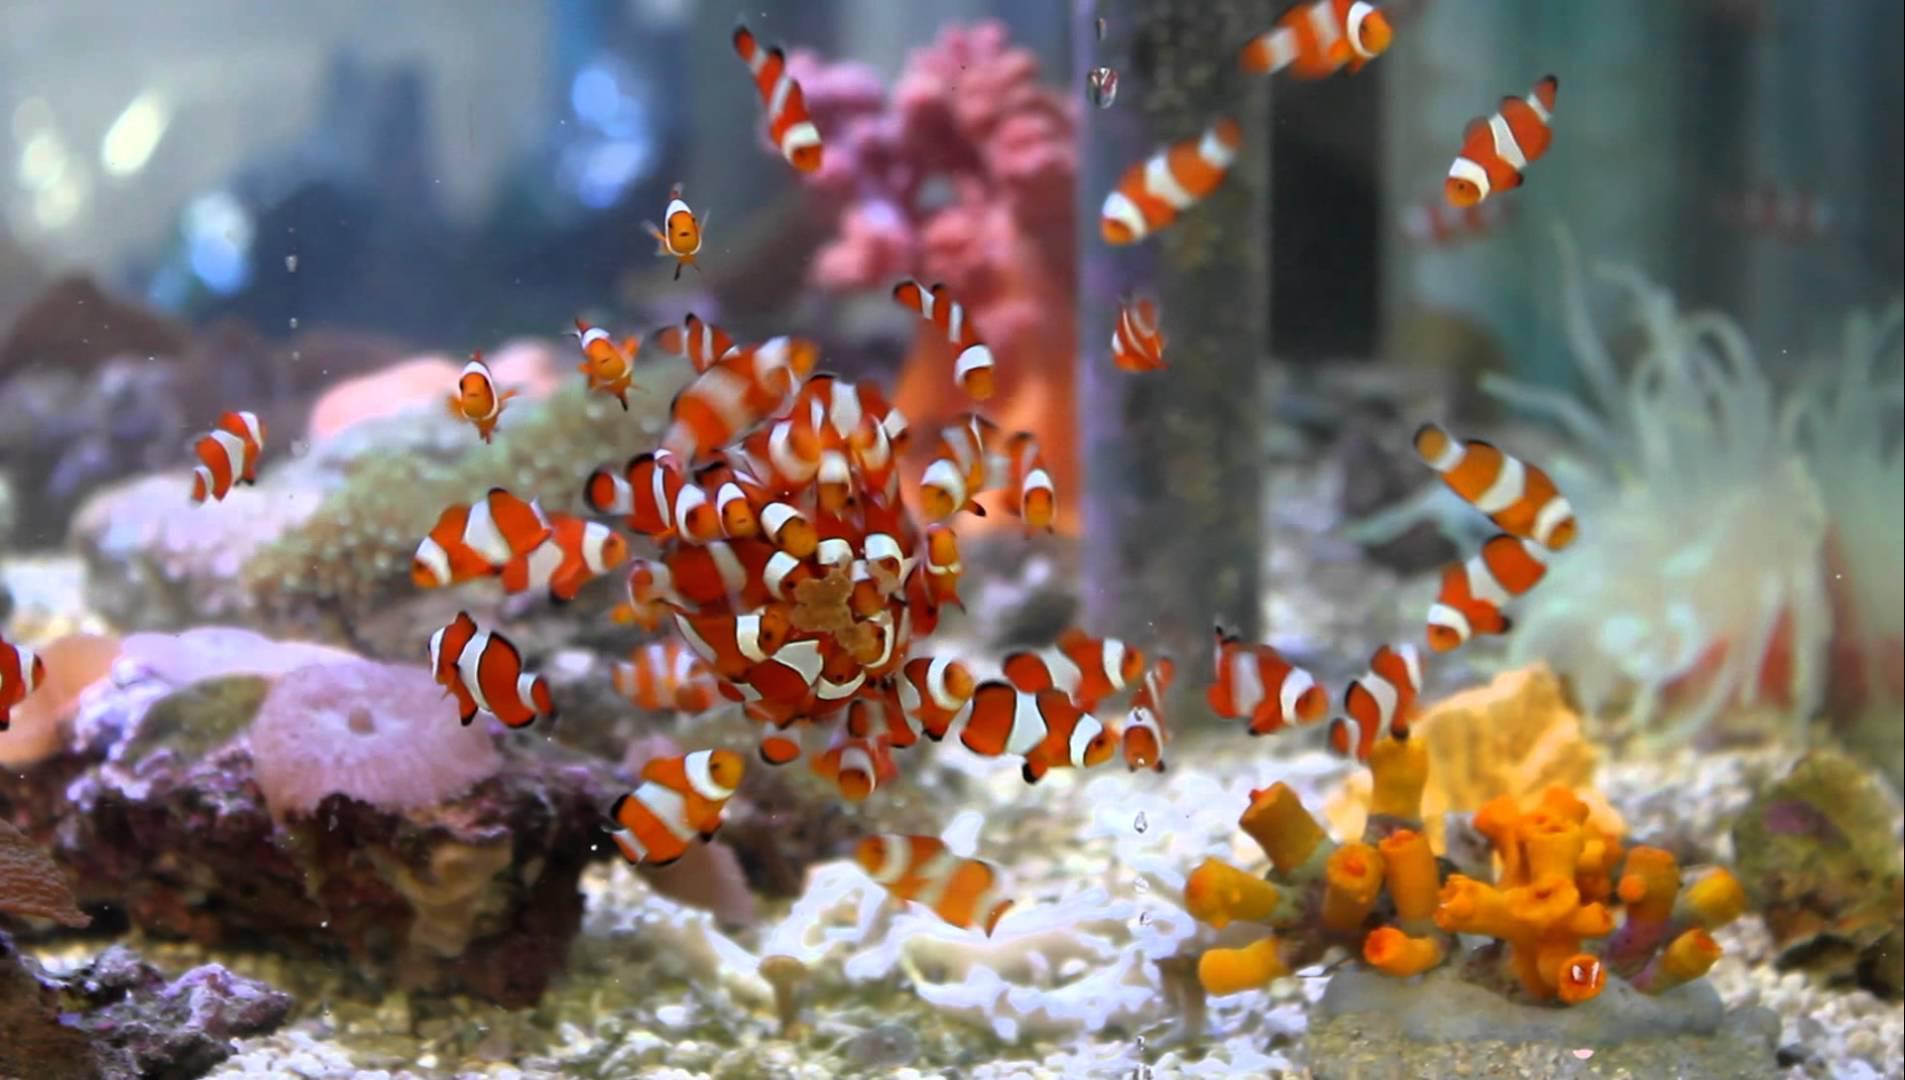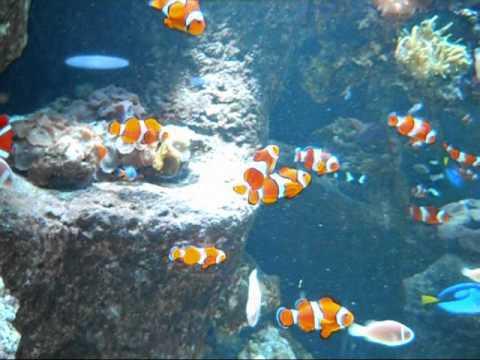The first image is the image on the left, the second image is the image on the right. Evaluate the accuracy of this statement regarding the images: "Each image features clownfish swimming in front of anemone tendrils, and no image contains more than four clownfish.". Is it true? Answer yes or no. No. 